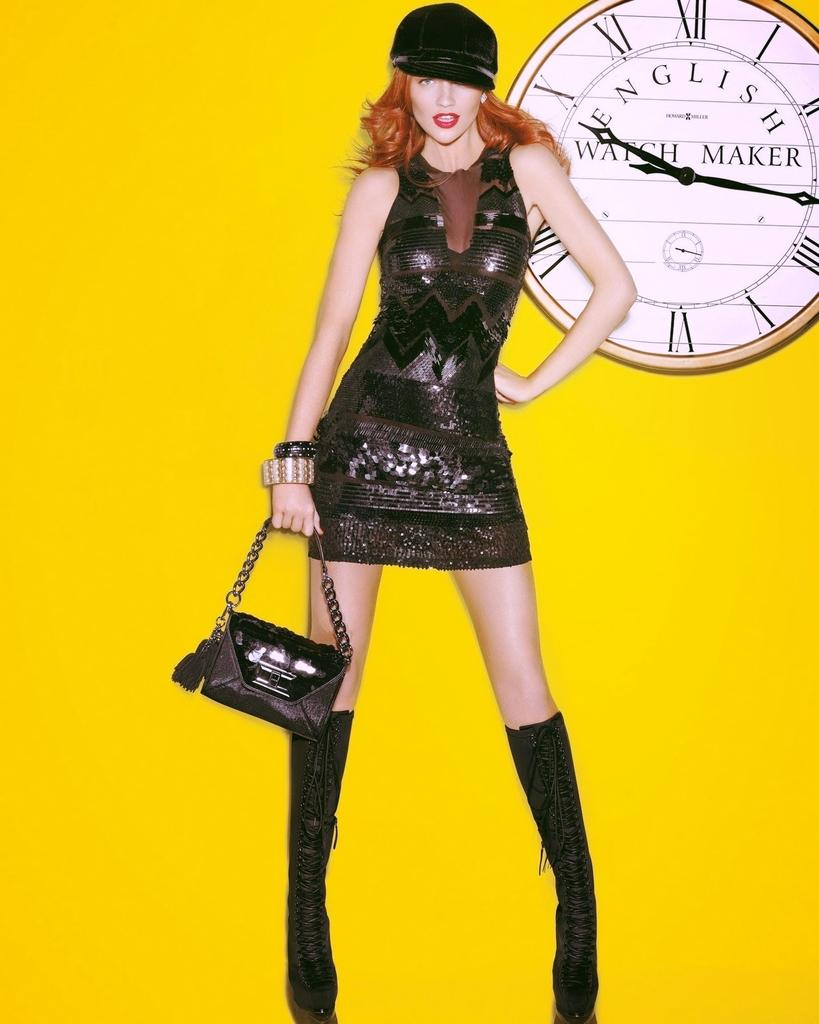What color is the wall in the background of the image? The wall in the background of the image is yellow. What object can be seen on the wall in the background? There is a clock on the wall in the background. What is the woman in the image wearing? The woman is wearing a black dress and a black hat. What accessory is the woman holding in the image? The woman is holding a black handbag. What type of friction is the woman experiencing while wearing the black dress in the image? There is no information about friction in the image, as it focuses on the visual appearance of the woman and her surroundings. 